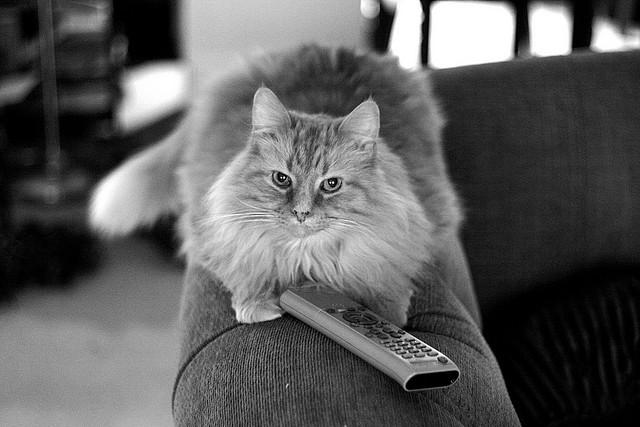How is the cat on the couch illuminated?

Choices:
A) moonlight
B) sunlight
C) led light
D) fluorescent light sunlight 